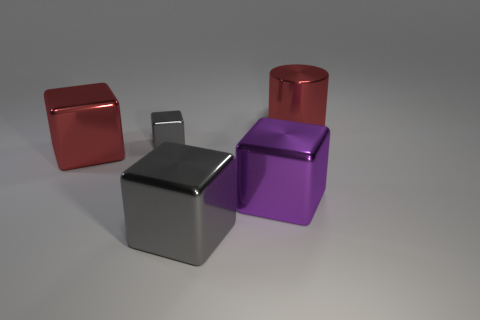Subtract all purple cubes. How many cubes are left? 3 Add 3 purple blocks. How many objects exist? 8 Subtract all red cubes. How many cubes are left? 3 Subtract all blocks. How many objects are left? 1 Subtract all yellow cylinders. How many gray blocks are left? 2 Add 5 small gray objects. How many small gray objects are left? 6 Add 3 purple objects. How many purple objects exist? 4 Subtract 0 green spheres. How many objects are left? 5 Subtract 1 cylinders. How many cylinders are left? 0 Subtract all blue cubes. Subtract all gray cylinders. How many cubes are left? 4 